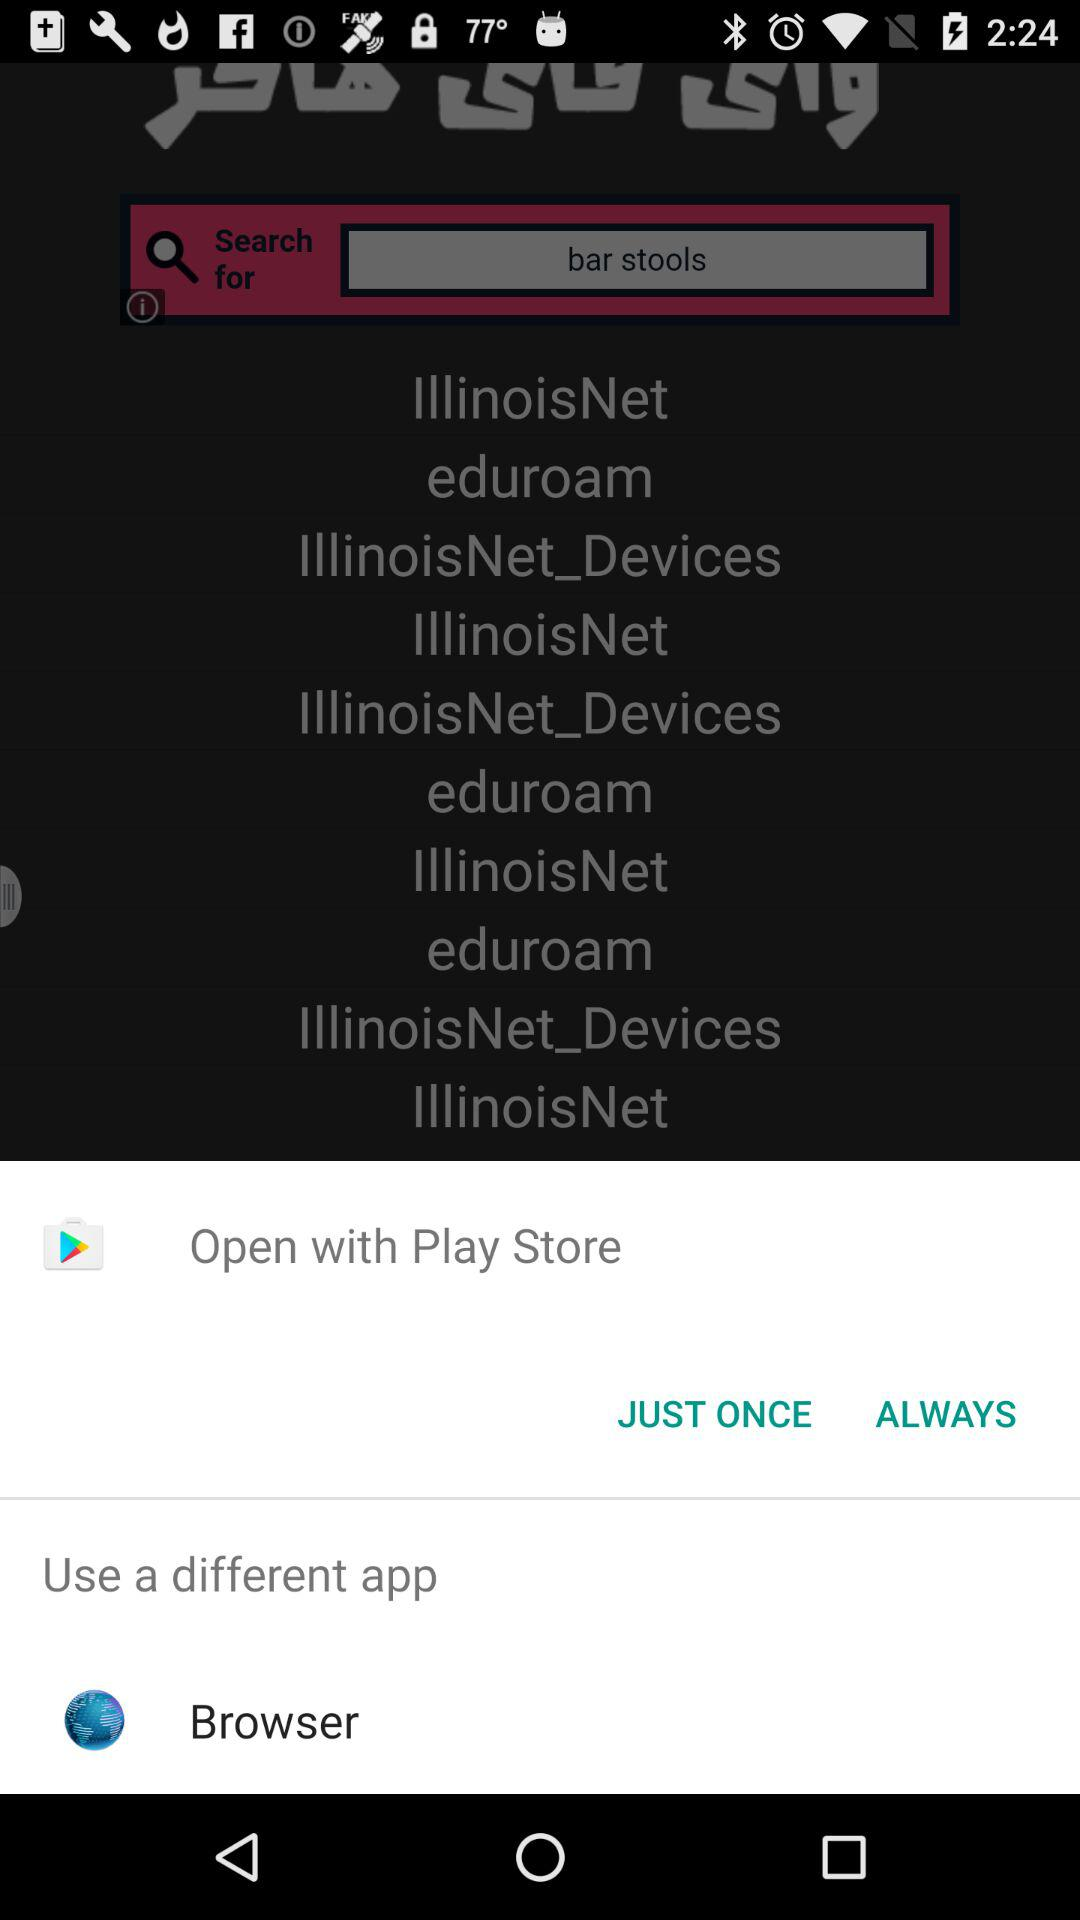What platforms can I use to open it? You can use "Play Store" to open it. 